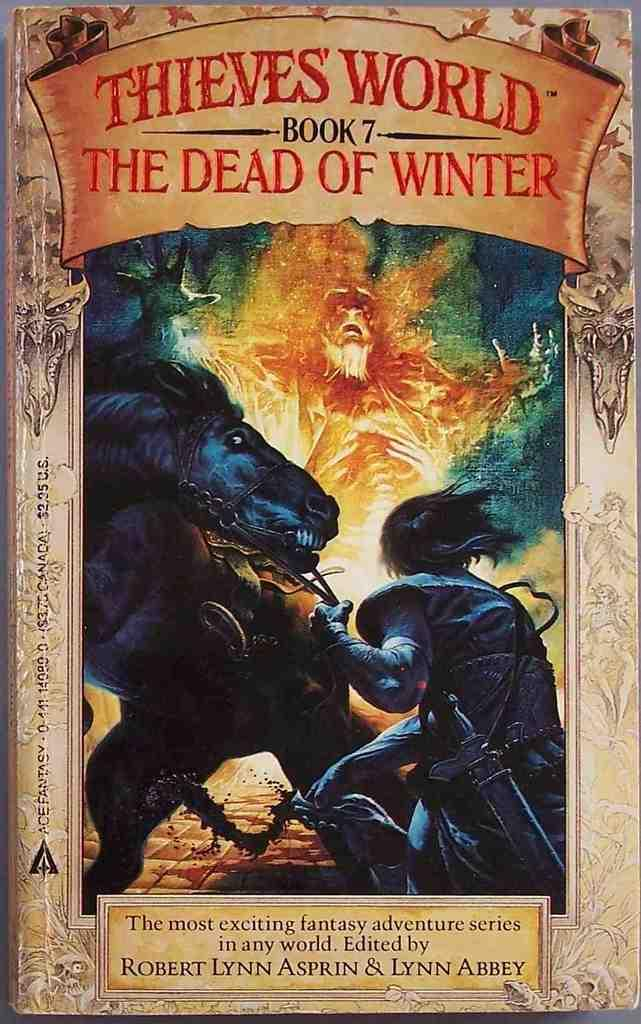<image>
Create a compact narrative representing the image presented. Book cover for Thieves World Book 7 showing a man handling his horse. 